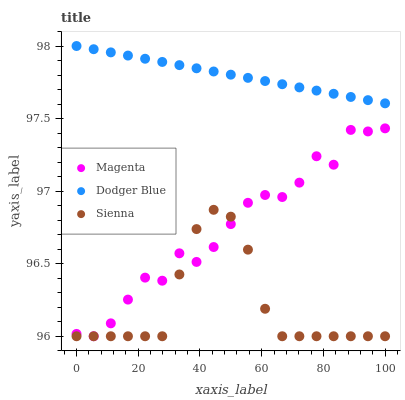Does Sienna have the minimum area under the curve?
Answer yes or no. Yes. Does Dodger Blue have the maximum area under the curve?
Answer yes or no. Yes. Does Magenta have the minimum area under the curve?
Answer yes or no. No. Does Magenta have the maximum area under the curve?
Answer yes or no. No. Is Dodger Blue the smoothest?
Answer yes or no. Yes. Is Magenta the roughest?
Answer yes or no. Yes. Is Magenta the smoothest?
Answer yes or no. No. Is Dodger Blue the roughest?
Answer yes or no. No. Does Sienna have the lowest value?
Answer yes or no. Yes. Does Dodger Blue have the lowest value?
Answer yes or no. No. Does Dodger Blue have the highest value?
Answer yes or no. Yes. Does Magenta have the highest value?
Answer yes or no. No. Is Sienna less than Dodger Blue?
Answer yes or no. Yes. Is Dodger Blue greater than Magenta?
Answer yes or no. Yes. Does Magenta intersect Sienna?
Answer yes or no. Yes. Is Magenta less than Sienna?
Answer yes or no. No. Is Magenta greater than Sienna?
Answer yes or no. No. Does Sienna intersect Dodger Blue?
Answer yes or no. No. 